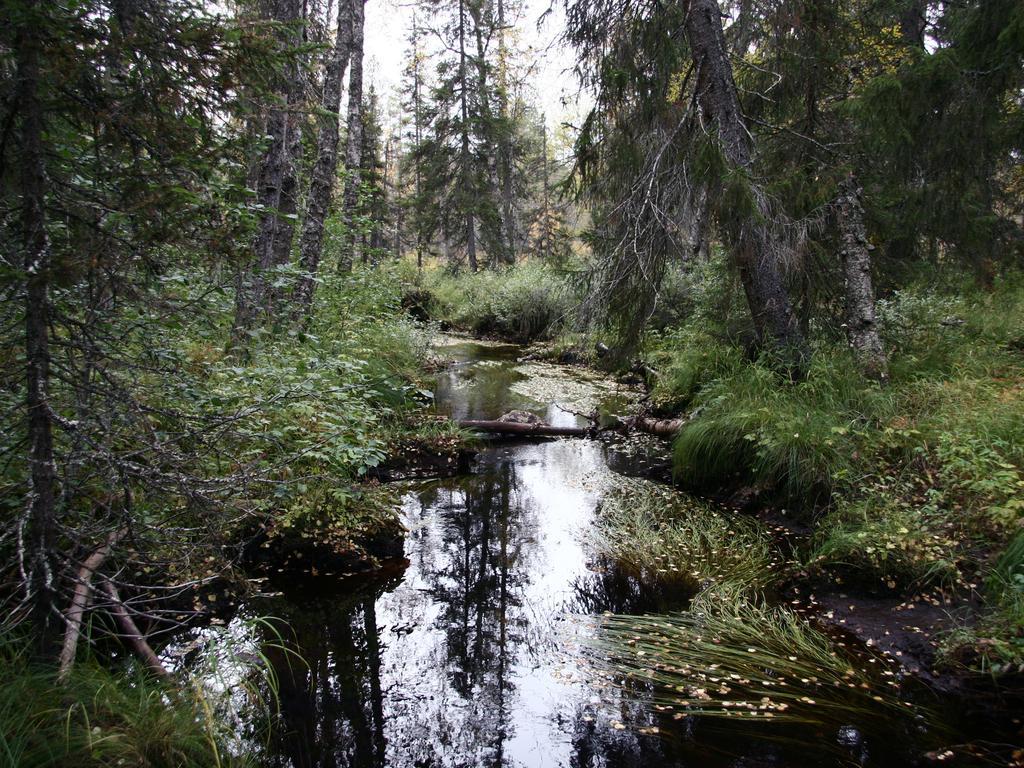In one or two sentences, can you explain what this image depicts? In the picture I can see the pond. There are trees on the left side and the right side as well. I can see planets on the right side. 